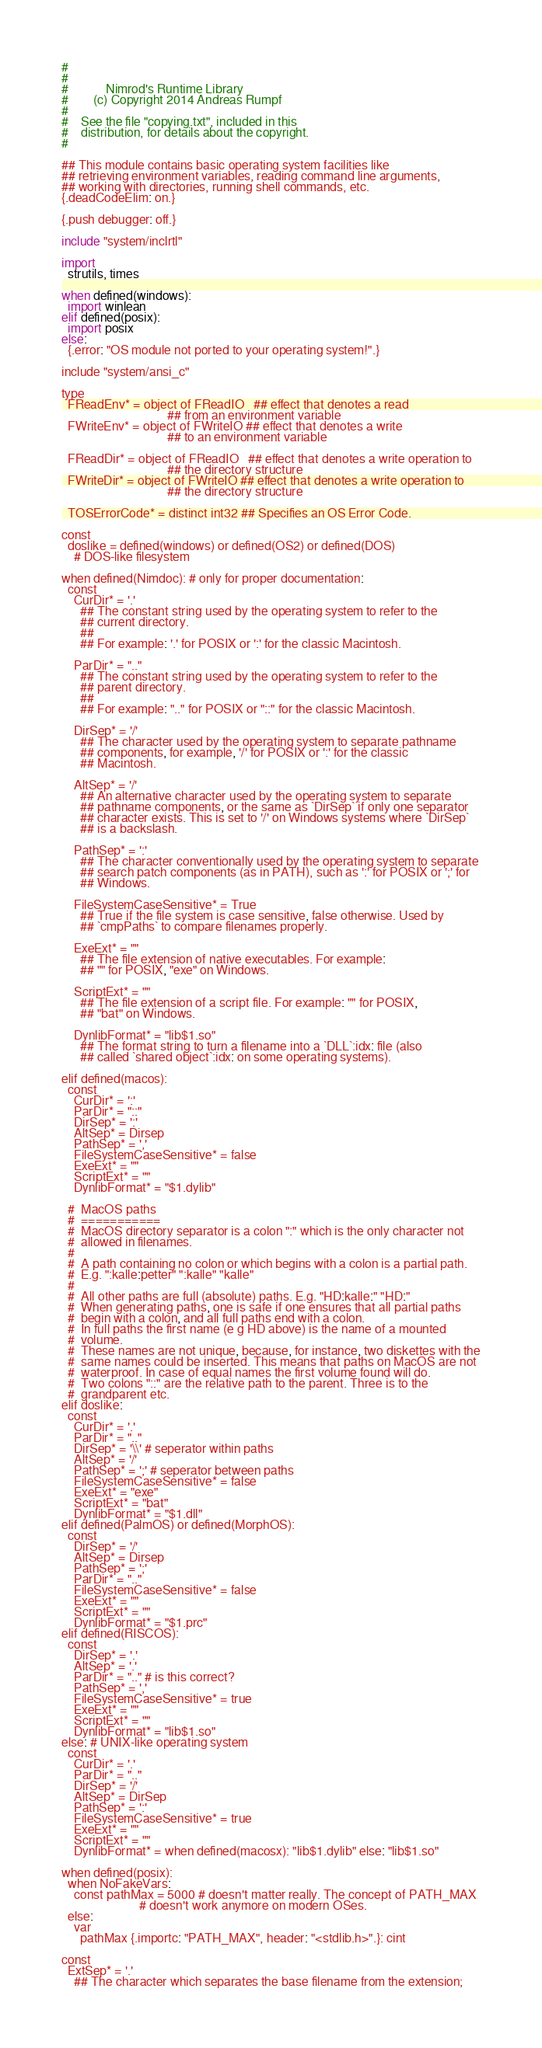<code> <loc_0><loc_0><loc_500><loc_500><_Nim_>#
#
#            Nimrod's Runtime Library
#        (c) Copyright 2014 Andreas Rumpf
#
#    See the file "copying.txt", included in this
#    distribution, for details about the copyright.
#

## This module contains basic operating system facilities like
## retrieving environment variables, reading command line arguments,
## working with directories, running shell commands, etc.
{.deadCodeElim: on.}

{.push debugger: off.}

include "system/inclrtl"

import
  strutils, times

when defined(windows):
  import winlean
elif defined(posix):
  import posix
else:
  {.error: "OS module not ported to your operating system!".}

include "system/ansi_c"

type
  FReadEnv* = object of FReadIO   ## effect that denotes a read
                                  ## from an environment variable
  FWriteEnv* = object of FWriteIO ## effect that denotes a write
                                  ## to an environment variable

  FReadDir* = object of FReadIO   ## effect that denotes a write operation to
                                  ## the directory structure
  FWriteDir* = object of FWriteIO ## effect that denotes a write operation to
                                  ## the directory structure

  TOSErrorCode* = distinct int32 ## Specifies an OS Error Code.

const
  doslike = defined(windows) or defined(OS2) or defined(DOS)
    # DOS-like filesystem

when defined(Nimdoc): # only for proper documentation:
  const
    CurDir* = '.'
      ## The constant string used by the operating system to refer to the
      ## current directory.
      ##
      ## For example: '.' for POSIX or ':' for the classic Macintosh.

    ParDir* = ".."
      ## The constant string used by the operating system to refer to the
      ## parent directory.
      ##
      ## For example: ".." for POSIX or "::" for the classic Macintosh.

    DirSep* = '/'
      ## The character used by the operating system to separate pathname
      ## components, for example, '/' for POSIX or ':' for the classic
      ## Macintosh.

    AltSep* = '/'
      ## An alternative character used by the operating system to separate
      ## pathname components, or the same as `DirSep` if only one separator
      ## character exists. This is set to '/' on Windows systems where `DirSep`
      ## is a backslash.

    PathSep* = ':'
      ## The character conventionally used by the operating system to separate
      ## search patch components (as in PATH), such as ':' for POSIX or ';' for
      ## Windows.

    FileSystemCaseSensitive* = True
      ## True if the file system is case sensitive, false otherwise. Used by
      ## `cmpPaths` to compare filenames properly.

    ExeExt* = ""
      ## The file extension of native executables. For example:
      ## "" for POSIX, "exe" on Windows.

    ScriptExt* = ""
      ## The file extension of a script file. For example: "" for POSIX,
      ## "bat" on Windows.

    DynlibFormat* = "lib$1.so"
      ## The format string to turn a filename into a `DLL`:idx: file (also
      ## called `shared object`:idx: on some operating systems).

elif defined(macos):
  const
    CurDir* = ':'
    ParDir* = "::"
    DirSep* = ':'
    AltSep* = Dirsep
    PathSep* = ','
    FileSystemCaseSensitive* = false
    ExeExt* = ""
    ScriptExt* = ""
    DynlibFormat* = "$1.dylib"

  #  MacOS paths
  #  ===========
  #  MacOS directory separator is a colon ":" which is the only character not
  #  allowed in filenames.
  #
  #  A path containing no colon or which begins with a colon is a partial path.
  #  E.g. ":kalle:petter" ":kalle" "kalle"
  #
  #  All other paths are full (absolute) paths. E.g. "HD:kalle:" "HD:"
  #  When generating paths, one is safe if one ensures that all partial paths
  #  begin with a colon, and all full paths end with a colon.
  #  In full paths the first name (e g HD above) is the name of a mounted
  #  volume.
  #  These names are not unique, because, for instance, two diskettes with the
  #  same names could be inserted. This means that paths on MacOS are not
  #  waterproof. In case of equal names the first volume found will do.
  #  Two colons "::" are the relative path to the parent. Three is to the
  #  grandparent etc.
elif doslike:
  const
    CurDir* = '.'
    ParDir* = ".."
    DirSep* = '\\' # seperator within paths
    AltSep* = '/'
    PathSep* = ';' # seperator between paths
    FileSystemCaseSensitive* = false
    ExeExt* = "exe"
    ScriptExt* = "bat"
    DynlibFormat* = "$1.dll"
elif defined(PalmOS) or defined(MorphOS):
  const
    DirSep* = '/'
    AltSep* = Dirsep
    PathSep* = ';'
    ParDir* = ".."
    FileSystemCaseSensitive* = false
    ExeExt* = ""
    ScriptExt* = ""
    DynlibFormat* = "$1.prc"
elif defined(RISCOS):
  const
    DirSep* = '.'
    AltSep* = '.'
    ParDir* = ".." # is this correct?
    PathSep* = ','
    FileSystemCaseSensitive* = true
    ExeExt* = ""
    ScriptExt* = ""
    DynlibFormat* = "lib$1.so"
else: # UNIX-like operating system
  const
    CurDir* = '.'
    ParDir* = ".."
    DirSep* = '/'
    AltSep* = DirSep
    PathSep* = ':'
    FileSystemCaseSensitive* = true
    ExeExt* = ""
    ScriptExt* = ""
    DynlibFormat* = when defined(macosx): "lib$1.dylib" else: "lib$1.so"

when defined(posix):
  when NoFakeVars:
    const pathMax = 5000 # doesn't matter really. The concept of PATH_MAX
                         # doesn't work anymore on modern OSes.
  else:
    var
      pathMax {.importc: "PATH_MAX", header: "<stdlib.h>".}: cint

const
  ExtSep* = '.'
    ## The character which separates the base filename from the extension;</code> 